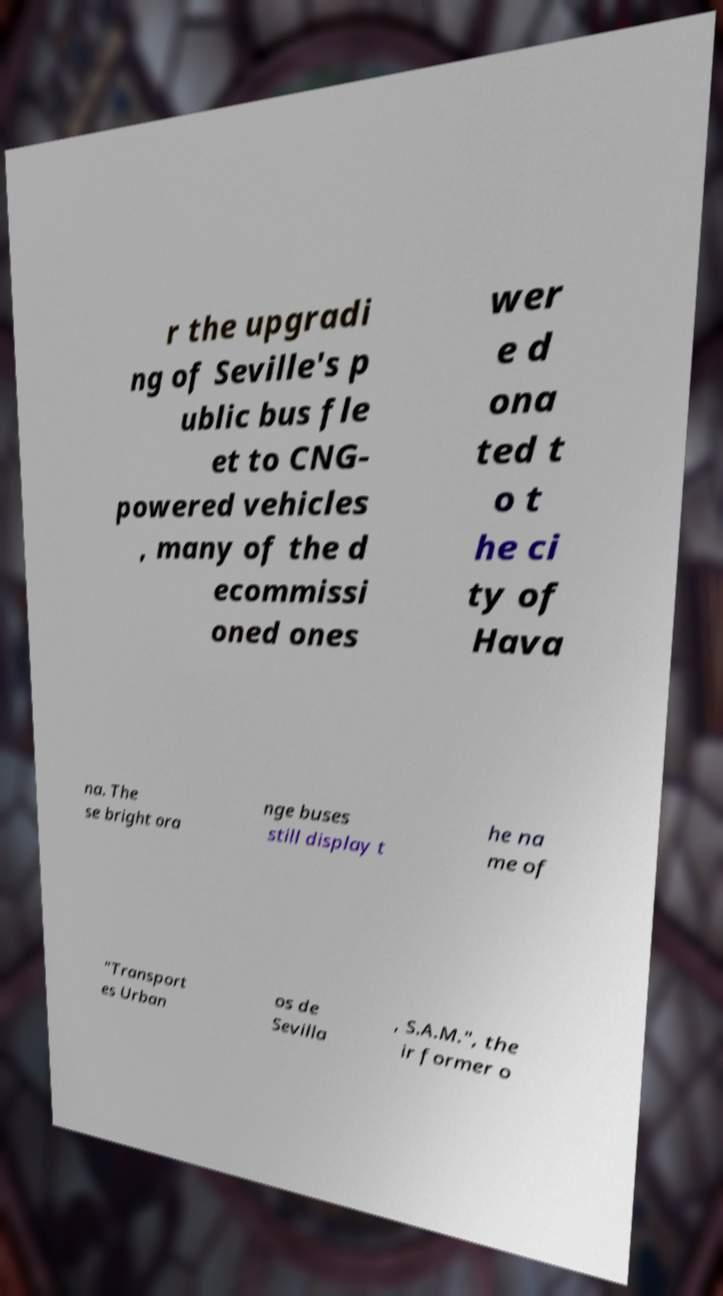Could you extract and type out the text from this image? r the upgradi ng of Seville's p ublic bus fle et to CNG- powered vehicles , many of the d ecommissi oned ones wer e d ona ted t o t he ci ty of Hava na. The se bright ora nge buses still display t he na me of "Transport es Urban os de Sevilla , S.A.M.", the ir former o 